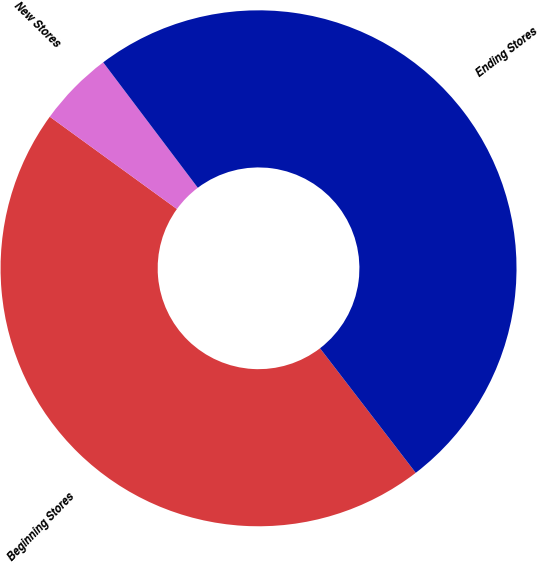Convert chart. <chart><loc_0><loc_0><loc_500><loc_500><pie_chart><fcel>Beginning Stores<fcel>New Stores<fcel>Ending Stores<nl><fcel>45.42%<fcel>4.72%<fcel>49.85%<nl></chart> 